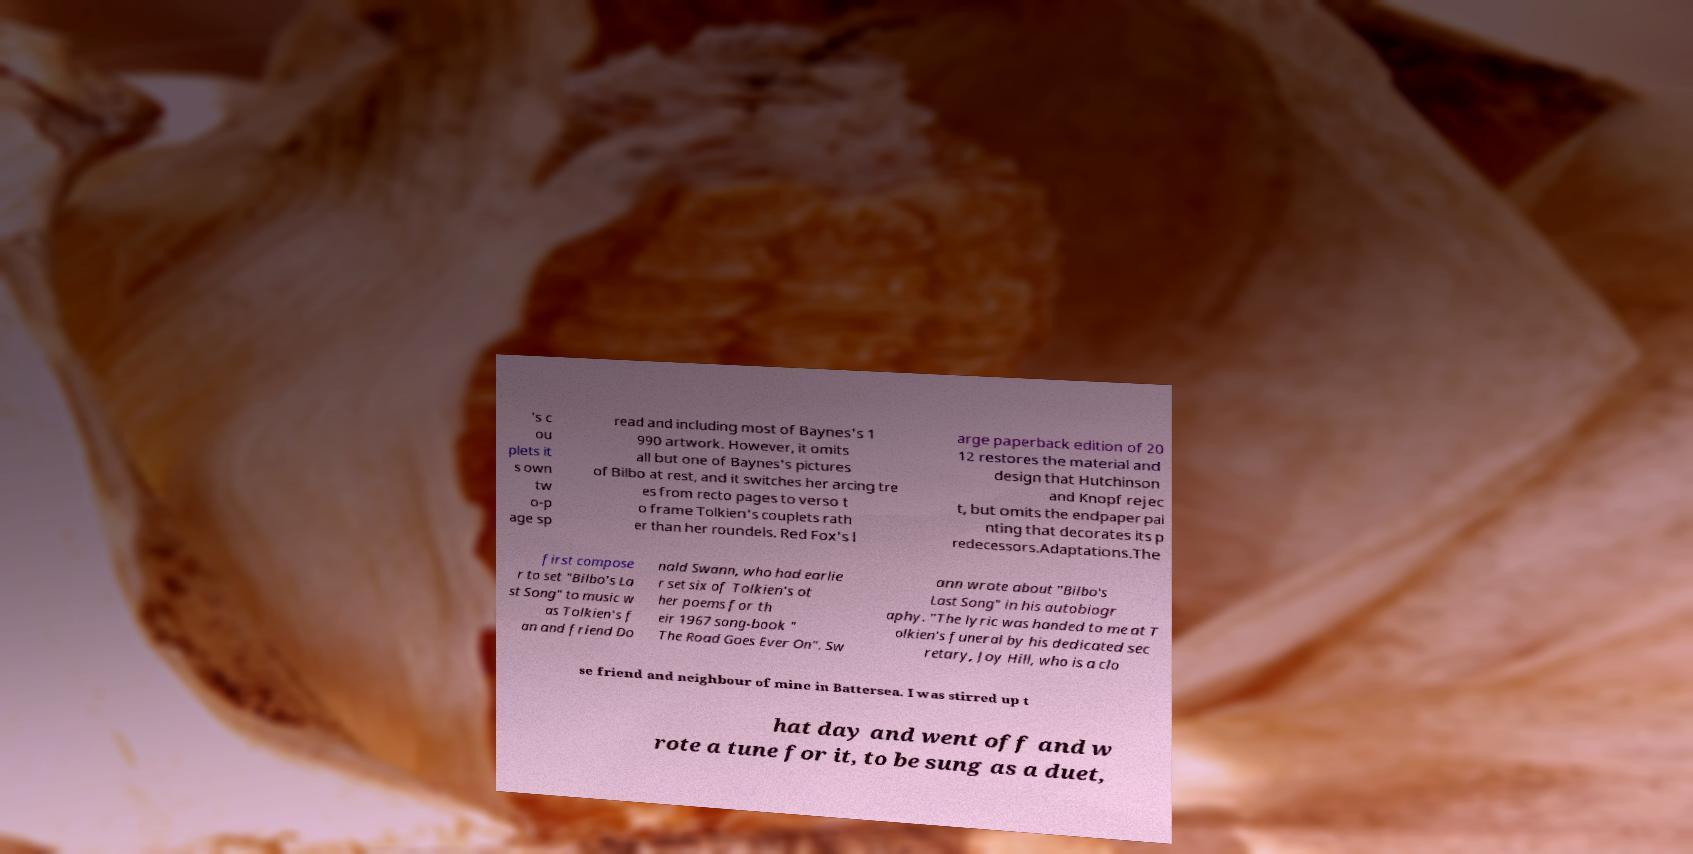Please identify and transcribe the text found in this image. 's c ou plets it s own tw o-p age sp read and including most of Baynes's 1 990 artwork. However, it omits all but one of Baynes's pictures of Bilbo at rest, and it switches her arcing tre es from recto pages to verso t o frame Tolkien's couplets rath er than her roundels. Red Fox's l arge paperback edition of 20 12 restores the material and design that Hutchinson and Knopf rejec t, but omits the endpaper pai nting that decorates its p redecessors.Adaptations.The first compose r to set "Bilbo's La st Song" to music w as Tolkien's f an and friend Do nald Swann, who had earlie r set six of Tolkien's ot her poems for th eir 1967 song-book " The Road Goes Ever On". Sw ann wrote about "Bilbo's Last Song" in his autobiogr aphy. "The lyric was handed to me at T olkien's funeral by his dedicated sec retary, Joy Hill, who is a clo se friend and neighbour of mine in Battersea. I was stirred up t hat day and went off and w rote a tune for it, to be sung as a duet, 